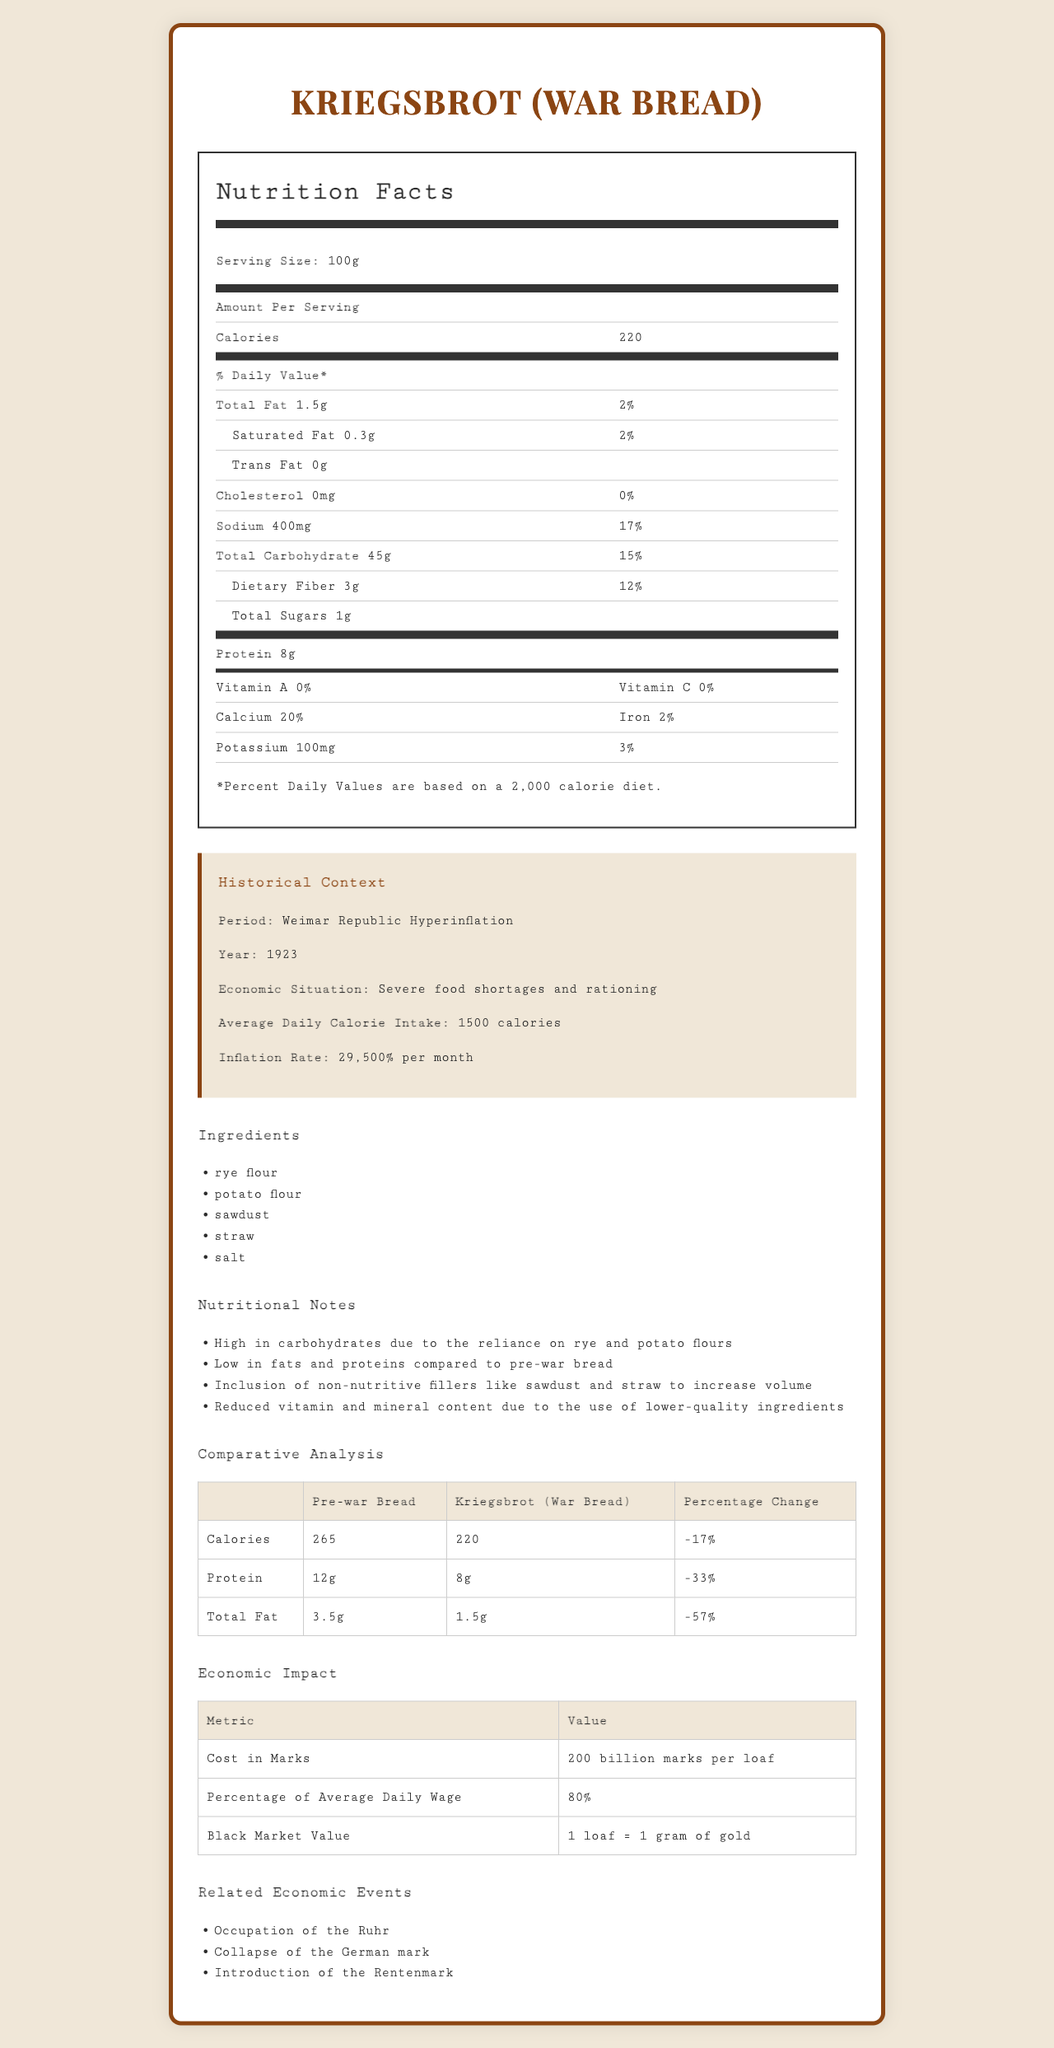what is the serving size of Kriegsbrot? The serving size is specified at the beginning of the nutrition facts label: "Serving Size: 100g".
Answer: 100g how many calories does one serving of Kriegsbrot contain? According to the nutrition facts, one serving of 100g Kriegsbrot contains 220 calories.
Answer: 220 how much sodium is in one serving of Kriegsbrot? The nutrition facts list the sodium content as 400mg per serving.
Answer: 400mg What are the ingredients used to make Kriegsbrot? The ingredients section lists rye flour, potato flour, sawdust, straw, and salt.
Answer: rye flour, potato flour, sawdust, straw, salt What is the historical period described in the document? The historical context explicitly states the period as "Weimar Republic Hyperinflation".
Answer: Weimar Republic Hyperinflation Which of the following best describes the economic situation during the Weimar Republic Hyperinflation? A. Economic boom and high employment B. Severe food shortages and rationing C. Stable prices and low inflation D. Technological advancements driving growth The historical context describes the economic situation as "severe food shortages and rationing".
Answer: B Which ingredient in Kriegsbrot is not typically found in modern bread? A. Rye flour B. Potato flour C. Sawdust D. Salt Sawdust is not a typical ingredient in modern bread, while rye flour, potato flour, and salt are more commonly used.
Answer: C True or False: The inclusion of non-nutritive fillers in Kriegsbrot was to increase its volume. The nutritional notes mention that non-nutritive fillers like sawdust and straw were included to increase volume.
Answer: True What percentage of an average daily wage did one loaf of Kriegsbrot cost during the Weimar Republic Hyperinflation? According to the economic impact section, one loaf of Kriegsbrot cost 80% of an average daily wage.
Answer: 80% What was the black market value of one loaf of Kriegsbrot? The economic impact section states that the black market value was equivalent to 1 gram of gold per loaf.
Answer: 1 loaf = 1 gram of gold Summarize the main idea of the document. The document encompasses various aspects of Kriegsbrot, from its nutritional breakdown and ingredients to the historical context, comparing it with pre-war bread, and detailing its economic significance in hyperinflationary Germany.
Answer: The document provides a detailed nutrition facts label for Kriegsbrot, a type of war bread from 1923 Germany during the Weimar Republic Hyperinflation. It includes its ingredients, nutritional value, historical context, and economic impact. The bread is notably low in fat and protein due to the use of low-quality fillers like sawdust and straw, and it cost a significant portion of daily wages during a time of severe food shortages and hyperinflation. What was the percentage change in calories from pre-war bread to Kriegsbrot? The comparative analysis section states the percentage change in calories as -17%.
Answer: -17% Is Kriegsbrot richer in protein compared to pre-war bread? The comparative analysis shows that Kriegsbrot has less protein (8g) compared to pre-war bread (12g) with a percentage change of -33%.
Answer: No Describe one nutritional note about Kriegsbrot. The nutritional notes section mentions that Kriegsbrot is high in carbohydrates because it relies on rye and potato flours.
Answer: High in carbohydrates due to the reliance on rye and potato flours What percentage of daily value is Potassium in Kriegsbrot? Potassium content is 100mg, and the percent daily value (3%) is calculated based on the daily requirement of 3500mg.
Answer: 3% What is the current inflation rate? The document only provides the inflation rate during the Weimar Republic Hyperinflation ("29,500% per month") without any reference to current inflation rates.
Answer: Not enough information 